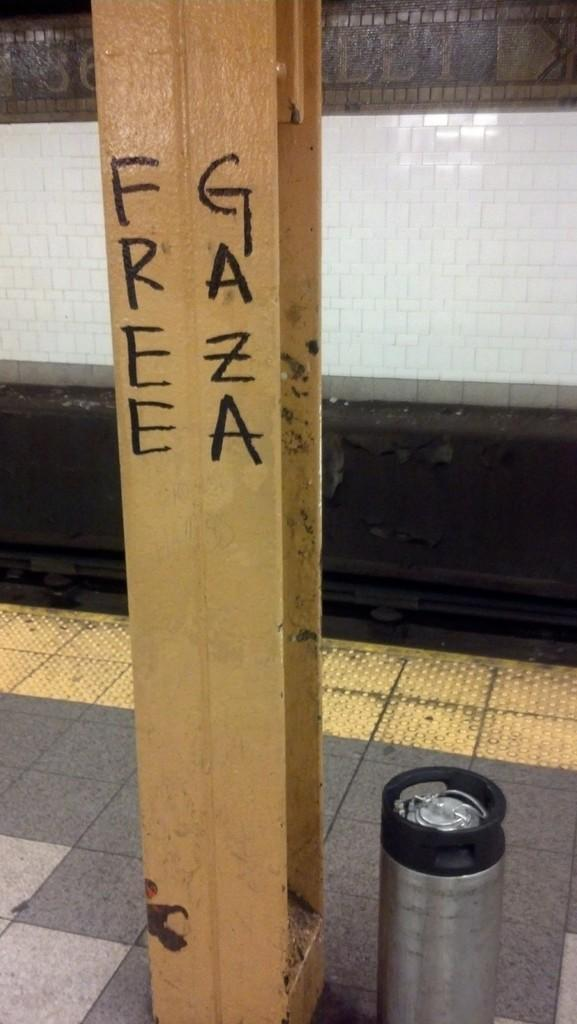<image>
Write a terse but informative summary of the picture. a beam in a subway reads Free Gaza 